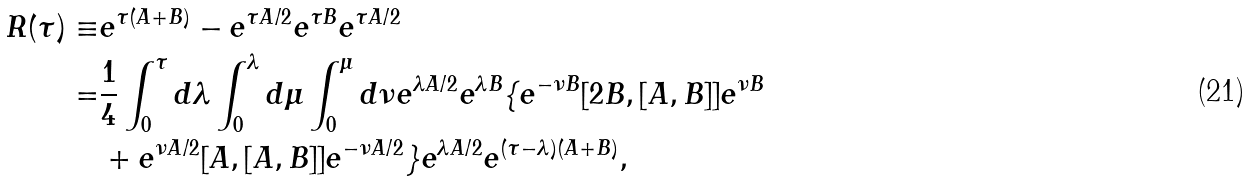<formula> <loc_0><loc_0><loc_500><loc_500>R ( \tau ) \equiv & e ^ { \tau ( A + B ) } - e ^ { \tau A / 2 } e ^ { \tau B } e ^ { \tau A / 2 } \\ = & \frac { 1 } { 4 } \int _ { 0 } ^ { \tau } d \lambda \int _ { 0 } ^ { \lambda } d \mu \int _ { 0 } ^ { \mu } d \nu e ^ { \lambda A / 2 } e ^ { \lambda B } \{ e ^ { - \nu B } [ 2 B , [ A , B ] ] e ^ { \nu B } \\ & + e ^ { \nu A / 2 } [ A , [ A , B ] ] e ^ { - \nu A / 2 } \} e ^ { \lambda A / 2 } e ^ { ( \tau - \lambda ) ( A + B ) } ,</formula> 